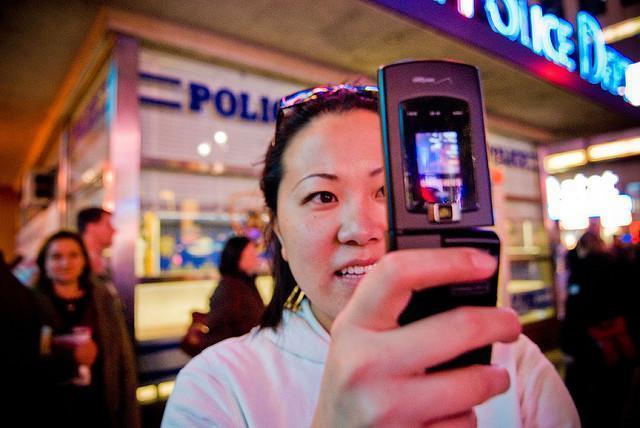How many people are in the photo?
Give a very brief answer. 4. 